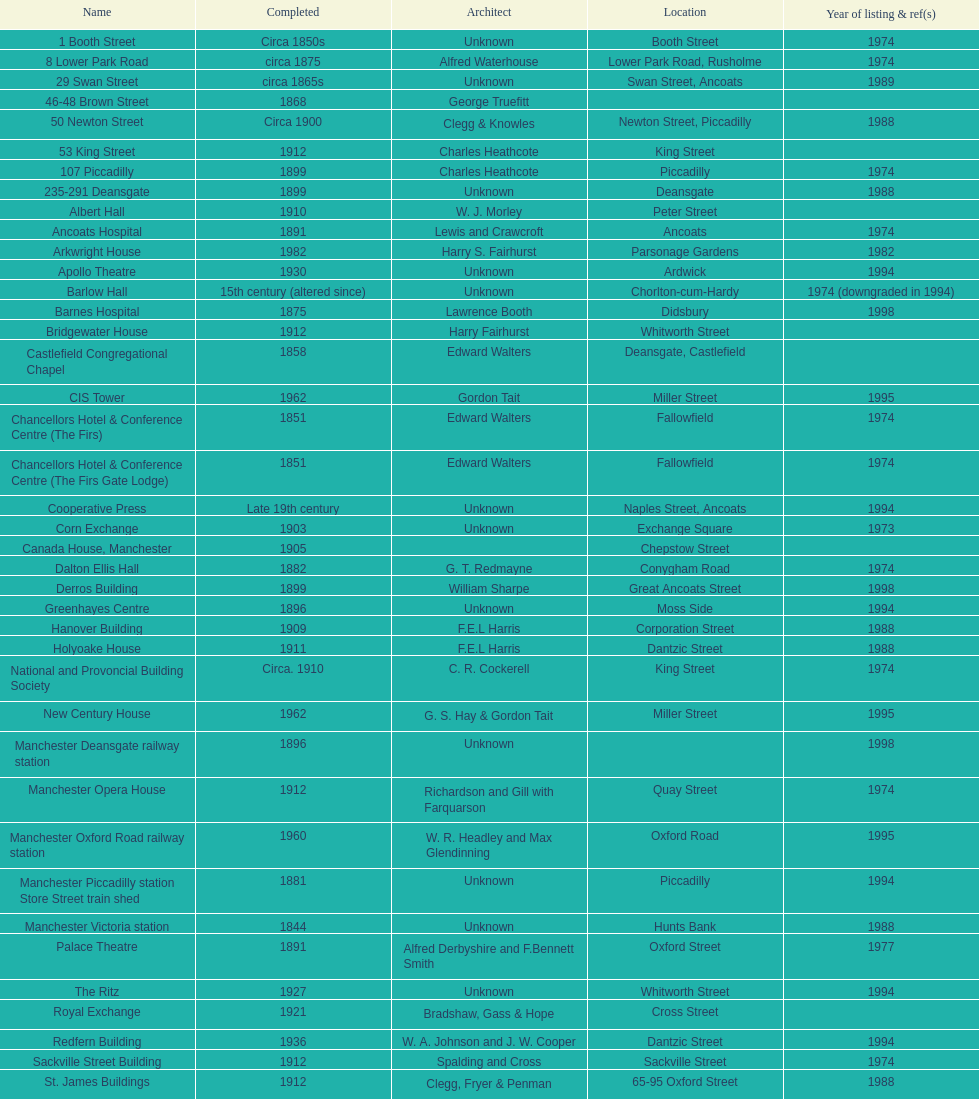What is the difference, in years, between the completion dates of 53 king street and castlefield congregational chapel? 54 years. 